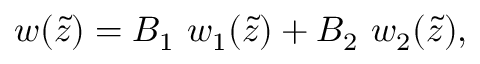Convert formula to latex. <formula><loc_0><loc_0><loc_500><loc_500>w ( \tilde { z } ) = B _ { 1 } \ w _ { 1 } ( \tilde { z } ) + B _ { 2 } \ w _ { 2 } ( \tilde { z } ) ,</formula> 